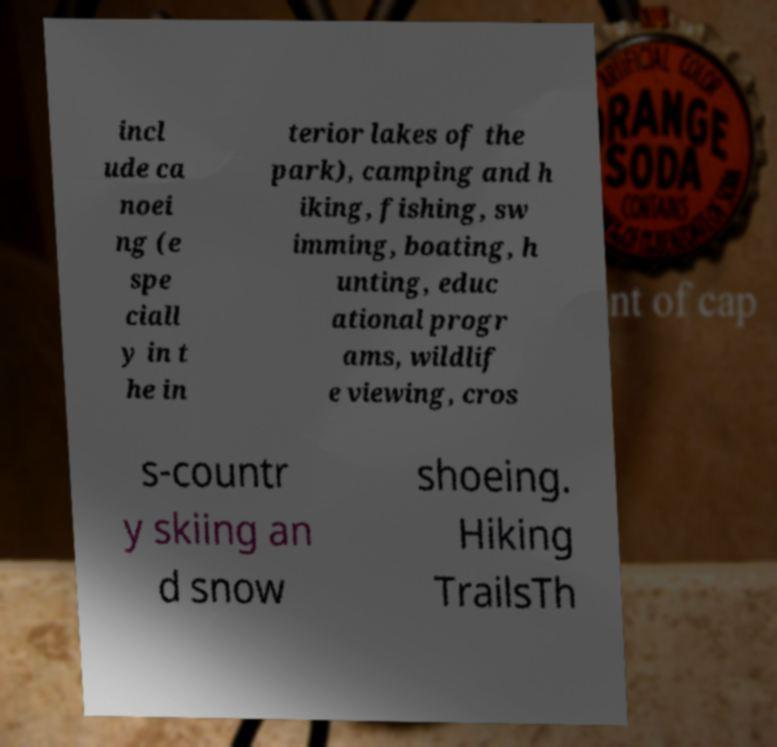For documentation purposes, I need the text within this image transcribed. Could you provide that? incl ude ca noei ng (e spe ciall y in t he in terior lakes of the park), camping and h iking, fishing, sw imming, boating, h unting, educ ational progr ams, wildlif e viewing, cros s-countr y skiing an d snow shoeing. Hiking TrailsTh 